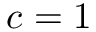<formula> <loc_0><loc_0><loc_500><loc_500>c = 1</formula> 